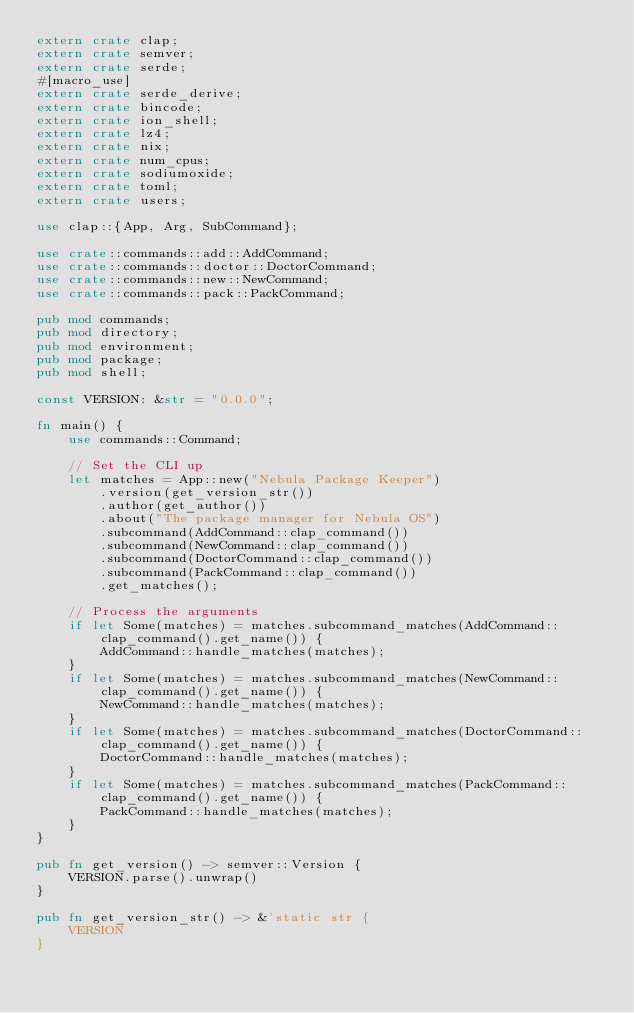<code> <loc_0><loc_0><loc_500><loc_500><_Rust_>extern crate clap;
extern crate semver;
extern crate serde;
#[macro_use]
extern crate serde_derive;
extern crate bincode;
extern crate ion_shell;
extern crate lz4;
extern crate nix;
extern crate num_cpus;
extern crate sodiumoxide;
extern crate toml;
extern crate users;

use clap::{App, Arg, SubCommand};

use crate::commands::add::AddCommand;
use crate::commands::doctor::DoctorCommand;
use crate::commands::new::NewCommand;
use crate::commands::pack::PackCommand;

pub mod commands;
pub mod directory;
pub mod environment;
pub mod package;
pub mod shell;

const VERSION: &str = "0.0.0";

fn main() {
    use commands::Command;

    // Set the CLI up
    let matches = App::new("Nebula Package Keeper")
        .version(get_version_str())
        .author(get_author())
        .about("The package manager for Nebula OS")
        .subcommand(AddCommand::clap_command())
        .subcommand(NewCommand::clap_command())
        .subcommand(DoctorCommand::clap_command())
        .subcommand(PackCommand::clap_command())
        .get_matches();

    // Process the arguments
    if let Some(matches) = matches.subcommand_matches(AddCommand::clap_command().get_name()) {
        AddCommand::handle_matches(matches);
    }
    if let Some(matches) = matches.subcommand_matches(NewCommand::clap_command().get_name()) {
        NewCommand::handle_matches(matches);
    }
    if let Some(matches) = matches.subcommand_matches(DoctorCommand::clap_command().get_name()) {
        DoctorCommand::handle_matches(matches);
    }
    if let Some(matches) = matches.subcommand_matches(PackCommand::clap_command().get_name()) {
        PackCommand::handle_matches(matches);
    }
}

pub fn get_version() -> semver::Version {
    VERSION.parse().unwrap()
}

pub fn get_version_str() -> &'static str {
    VERSION
}
</code> 